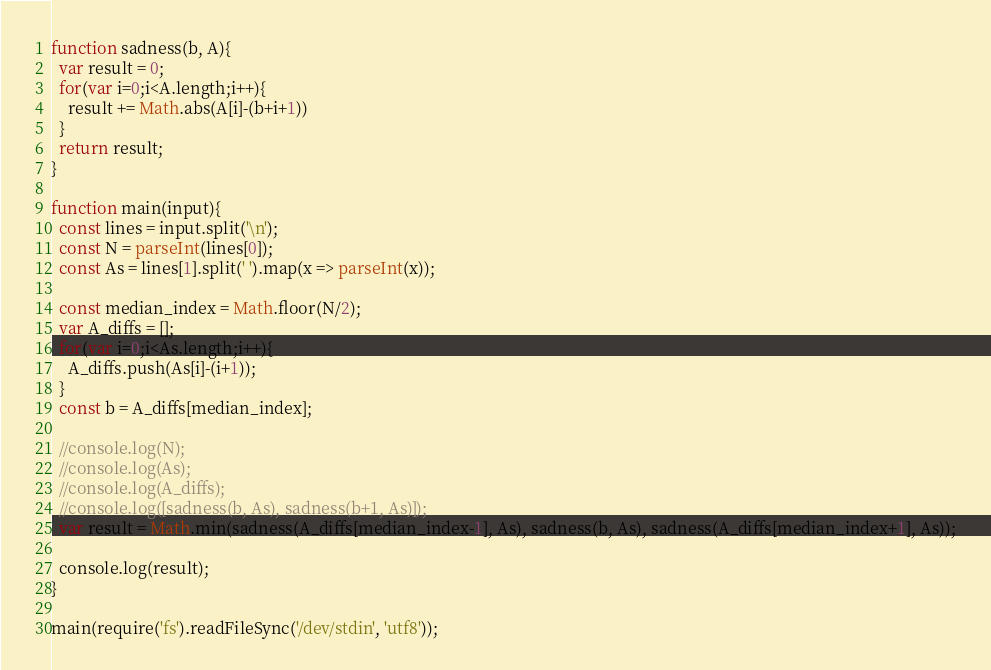Convert code to text. <code><loc_0><loc_0><loc_500><loc_500><_JavaScript_>function sadness(b, A){
  var result = 0;
  for(var i=0;i<A.length;i++){
    result += Math.abs(A[i]-(b+i+1))
  }
  return result;
}

function main(input){
  const lines = input.split('\n');
  const N = parseInt(lines[0]);
  const As = lines[1].split(' ').map(x => parseInt(x));

  const median_index = Math.floor(N/2);
  var A_diffs = [];
  for(var i=0;i<As.length;i++){
    A_diffs.push(As[i]-(i+1));
  }
  const b = A_diffs[median_index];

  //console.log(N);
  //console.log(As);
  //console.log(A_diffs);
  //console.log([sadness(b, As), sadness(b+1, As)]);
  var result = Math.min(sadness(A_diffs[median_index-1], As), sadness(b, As), sadness(A_diffs[median_index+1], As));

  console.log(result);
}

main(require('fs').readFileSync('/dev/stdin', 'utf8'));
</code> 